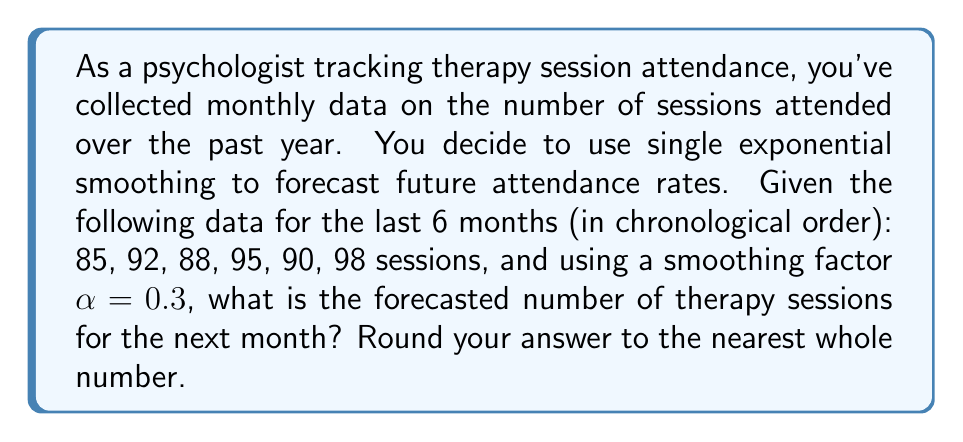Can you solve this math problem? To solve this problem using single exponential smoothing, we'll follow these steps:

1) The formula for single exponential smoothing is:

   $$F_{t+1} = \alpha Y_t + (1-\alpha)F_t$$

   Where:
   $F_{t+1}$ is the forecast for the next period
   $\alpha$ is the smoothing factor (0.3 in this case)
   $Y_t$ is the actual value for the current period
   $F_t$ is the forecast for the current period

2) We need to initialize $F_1$. A common method is to use the first observed value. So, $F_1 = 85$.

3) Now we can calculate the forecasts for each period:

   $F_2 = 0.3(85) + 0.7(85) = 85$
   $F_3 = 0.3(92) + 0.7(85) = 87.1$
   $F_4 = 0.3(88) + 0.7(87.1) = 87.37$
   $F_5 = 0.3(95) + 0.7(87.37) = 89.759$
   $F_6 = 0.3(90) + 0.7(89.759) = 89.8313$

4) For the final forecast:

   $F_7 = 0.3(98) + 0.7(89.8313) = 92.28191$

5) Rounding to the nearest whole number:

   92.28191 ≈ 92
Answer: 92 sessions 